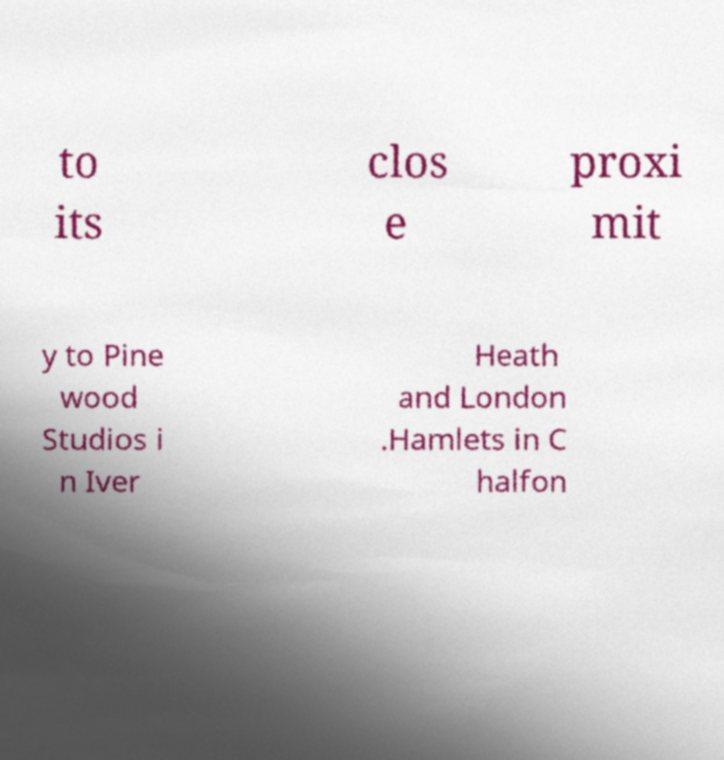For documentation purposes, I need the text within this image transcribed. Could you provide that? to its clos e proxi mit y to Pine wood Studios i n Iver Heath and London .Hamlets in C halfon 